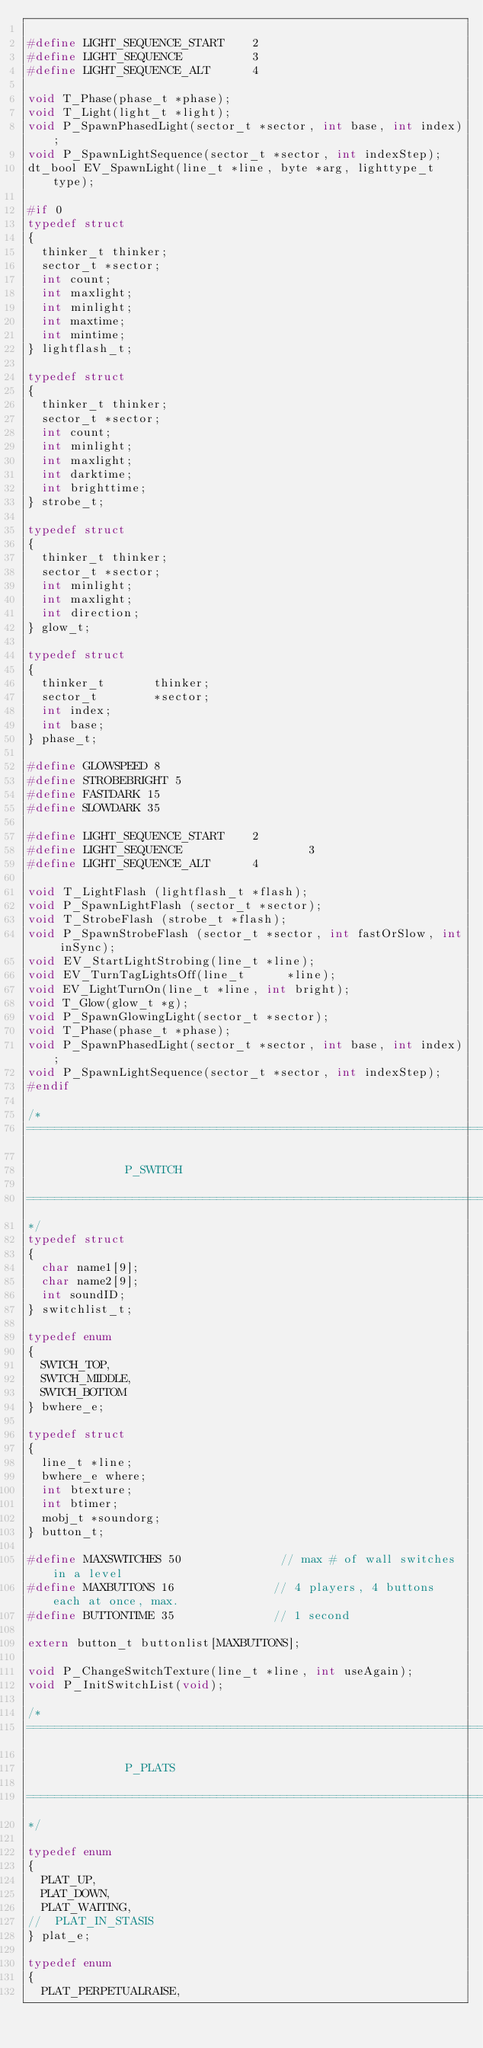<code> <loc_0><loc_0><loc_500><loc_500><_C_>
#define LIGHT_SEQUENCE_START    2
#define LIGHT_SEQUENCE          3
#define LIGHT_SEQUENCE_ALT      4

void T_Phase(phase_t *phase);
void T_Light(light_t *light);
void P_SpawnPhasedLight(sector_t *sector, int base, int index);
void P_SpawnLightSequence(sector_t *sector, int indexStep);
dt_bool EV_SpawnLight(line_t *line, byte *arg, lighttype_t type);

#if 0
typedef struct
{
	thinker_t thinker;
	sector_t *sector;
	int count;
	int maxlight;
	int minlight;
	int maxtime;
	int mintime;
} lightflash_t;

typedef struct
{
	thinker_t thinker;
	sector_t *sector;
	int count;
	int minlight;
	int maxlight;
	int darktime;
	int brighttime;
} strobe_t;

typedef struct
{
	thinker_t thinker;
	sector_t *sector;
	int minlight;
	int maxlight;
	int direction;
} glow_t;

typedef struct
{
	thinker_t       thinker;
	sector_t        *sector;
	int index;
	int base;
} phase_t;

#define GLOWSPEED 8
#define STROBEBRIGHT 5
#define FASTDARK 15
#define SLOWDARK 35

#define LIGHT_SEQUENCE_START    2
#define LIGHT_SEQUENCE                  3
#define LIGHT_SEQUENCE_ALT      4

void T_LightFlash (lightflash_t *flash);
void P_SpawnLightFlash (sector_t *sector);
void T_StrobeFlash (strobe_t *flash);
void P_SpawnStrobeFlash (sector_t *sector, int fastOrSlow, int inSync);
void EV_StartLightStrobing(line_t *line);
void EV_TurnTagLightsOff(line_t      *line);
void EV_LightTurnOn(line_t *line, int bright);
void T_Glow(glow_t *g);
void P_SpawnGlowingLight(sector_t *sector);
void T_Phase(phase_t *phase);
void P_SpawnPhasedLight(sector_t *sector, int base, int index);
void P_SpawnLightSequence(sector_t *sector, int indexStep);
#endif

/*
===============================================================================

							P_SWITCH

===============================================================================
*/
typedef struct
{
	char name1[9];
	char name2[9];
	int soundID;
} switchlist_t;

typedef enum
{
	SWTCH_TOP,
	SWTCH_MIDDLE,
	SWTCH_BOTTOM
} bwhere_e;

typedef struct
{
	line_t *line;
	bwhere_e where;
	int btexture;
	int btimer;
	mobj_t *soundorg;
} button_t;

#define MAXSWITCHES 50              // max # of wall switches in a level
#define MAXBUTTONS 16              // 4 players, 4 buttons each at once, max.
#define BUTTONTIME 35              // 1 second

extern button_t buttonlist[MAXBUTTONS];

void P_ChangeSwitchTexture(line_t *line, int useAgain);
void P_InitSwitchList(void);

/*
===============================================================================

							P_PLATS

===============================================================================
*/

typedef enum
{
	PLAT_UP,
	PLAT_DOWN,
	PLAT_WAITING,
//	PLAT_IN_STASIS
} plat_e;

typedef enum
{
	PLAT_PERPETUALRAISE,</code> 